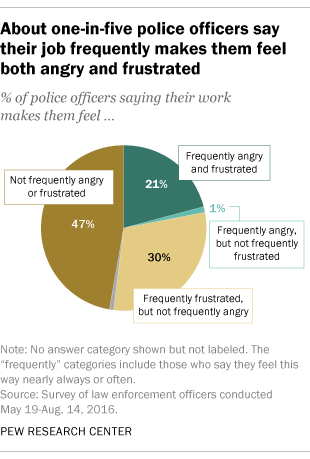Give some essential details in this illustration. What is the median of the largest segment of three numbers? Yes, the percentage value of the largest segment is 47. 